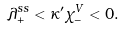<formula> <loc_0><loc_0><loc_500><loc_500>\lambda _ { + } ^ { s s } < \kappa ^ { \prime } \chi _ { - } ^ { V } < 0 .</formula> 